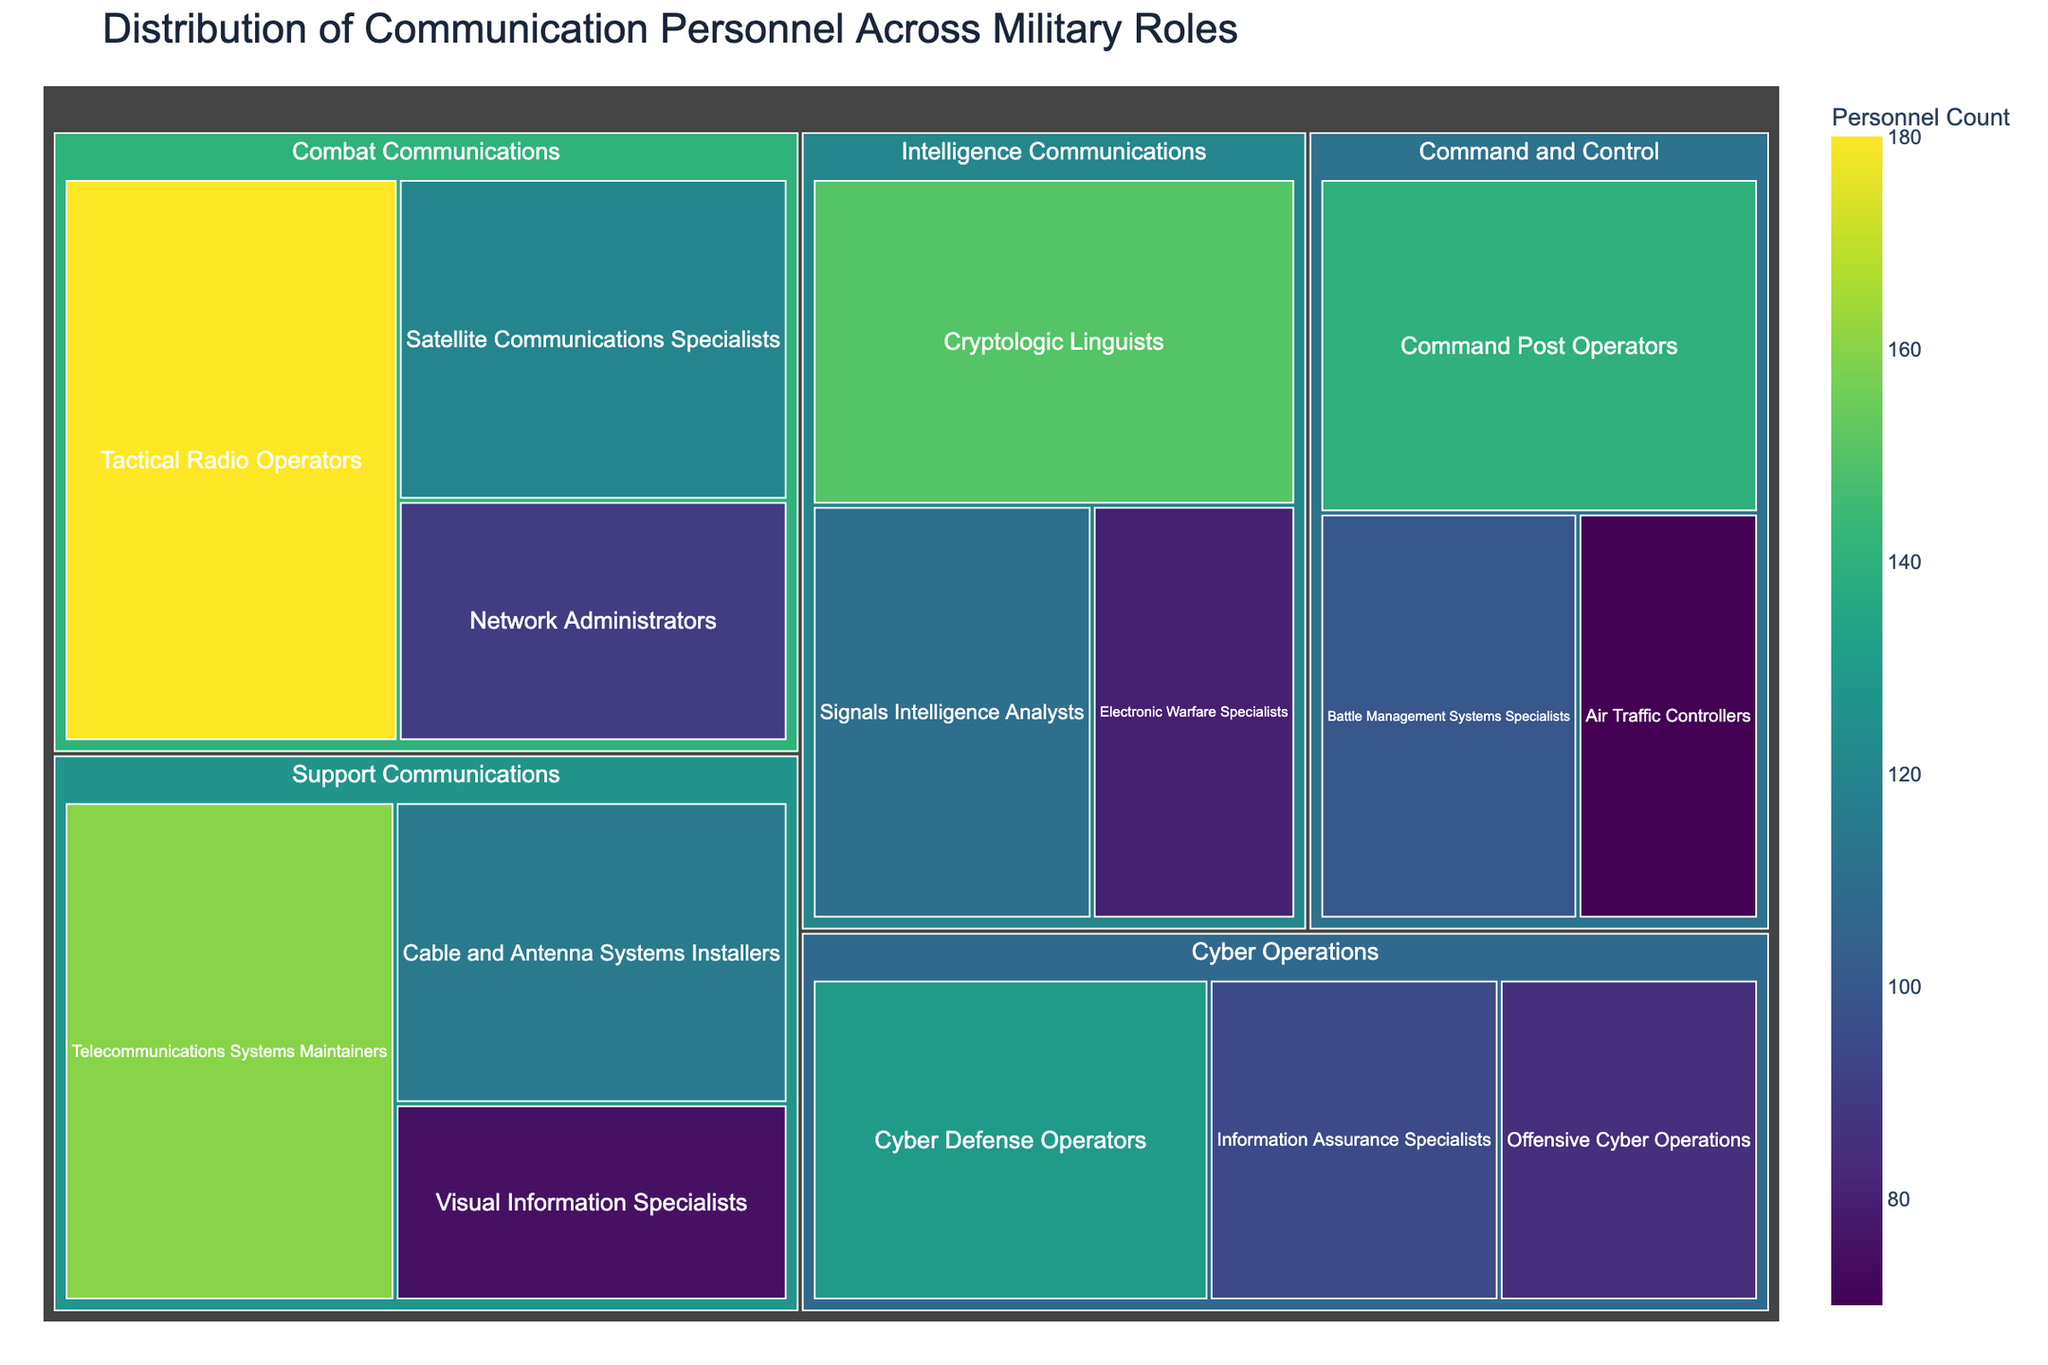what is the title of the treemap? The title of the treemap is provided at the top of the figure which gives an overview of the content being displayed.
Answer: Distribution of Communication Personnel Across Military Roles What category has the highest number of personnel? Find the category with the highest value by looking at the size of the sections in the treemap and identifying which has the largest total number of personnel.
Answer: Combat Communications Which category has the least number of personnel? Compare the aggregate values for each category to find the one with the lowest total personnel.
Answer: Cyber Operations What is the total number of personnel in the 'Command and Control' category? Sum the values of all subgroups under the 'Command and Control' category: (140 + 100 + 70).
Answer: 310 How does the number of Cryptologic Linguists compare to Signals Intelligence Analysts? Compare the values associated with each subgroup within the Intelligence Communications category: Cryptologic Linguists (150) and Signals Intelligence Analysts (110).
Answer: Cryptologic Linguists have 40 more personnel than Signals Intelligence Analysts Which subgroup within 'Support Communications' has the largest number of personnel? Look at the individual subgroups within 'Support Communications' and identify the one with the highest value.
Answer: Telecommunications Systems Maintainers How many subgroups are there in the 'Cyber Operations' category? Count the number of distinct boxes within the 'Cyber Operations' section of the treemap.
Answer: 3 What is the difference in personnel count between Tactical Radio Operators and Air Traffic Controllers? Calculate the difference between the values for Tactical Radio Operators (180) and Air Traffic Controllers (70).
Answer: 110 Which subgroup in 'Combat Communications' has the least number of personnel? Compare the values within the 'Combat Communications' subgroups: Tactical Radio Operators (180), Satellite Communications Specialists (120), Network Administrators (90) and identify the smallest value.
Answer: Network Administrators What color range is used to represent the personnel count in the treemap? The treemap uses a color scale to represent different personnel counts; identify this color range by observing the spectrum displayed on the color bar.
Answer: Viridis scale (ranging from yellow-green to dark blue) 